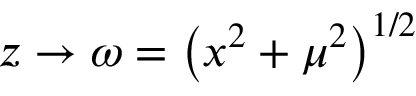<formula> <loc_0><loc_0><loc_500><loc_500>z \rightarrow \omega = \left ( x ^ { 2 } + \mu ^ { 2 } \right ) ^ { 1 / 2 }</formula> 